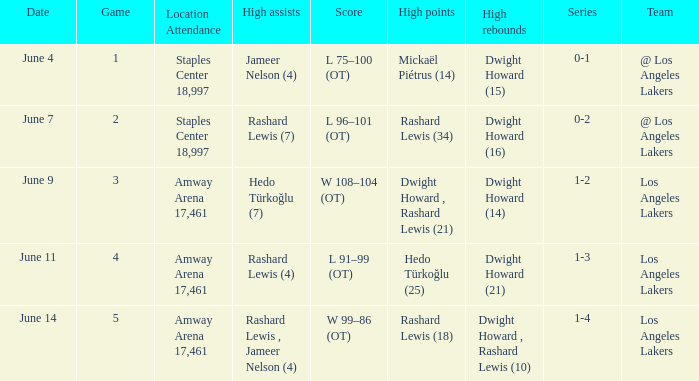What is High Points, when High Rebounds is "Dwight Howard (16)"? Rashard Lewis (34). 